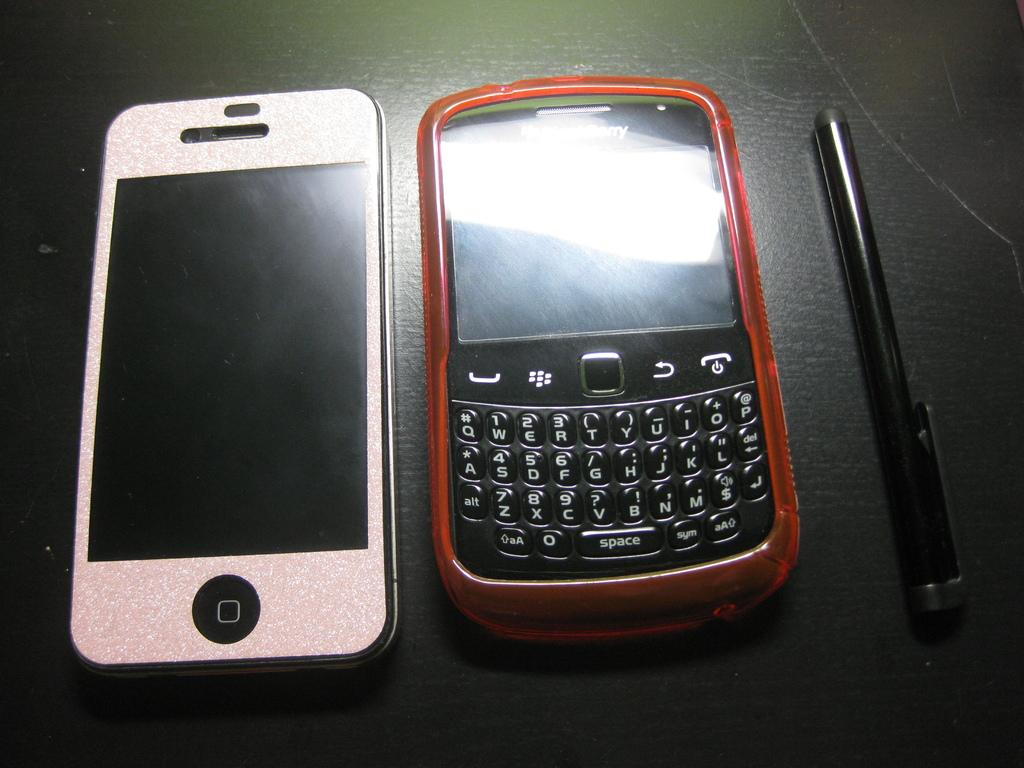<image>
Offer a succinct explanation of the picture presented. A smart phone is next palm pilot with a keypad that includes letters, numbers, and a "space" and "syn" key 